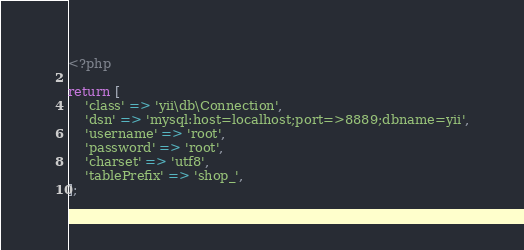Convert code to text. <code><loc_0><loc_0><loc_500><loc_500><_PHP_><?php

return [
    'class' => 'yii\db\Connection',
    'dsn' => 'mysql:host=localhost;port=>8889;dbname=yii',
    'username' => 'root',
    'password' => 'root',
    'charset' => 'utf8',
    'tablePrefix' => 'shop_',
];
</code> 